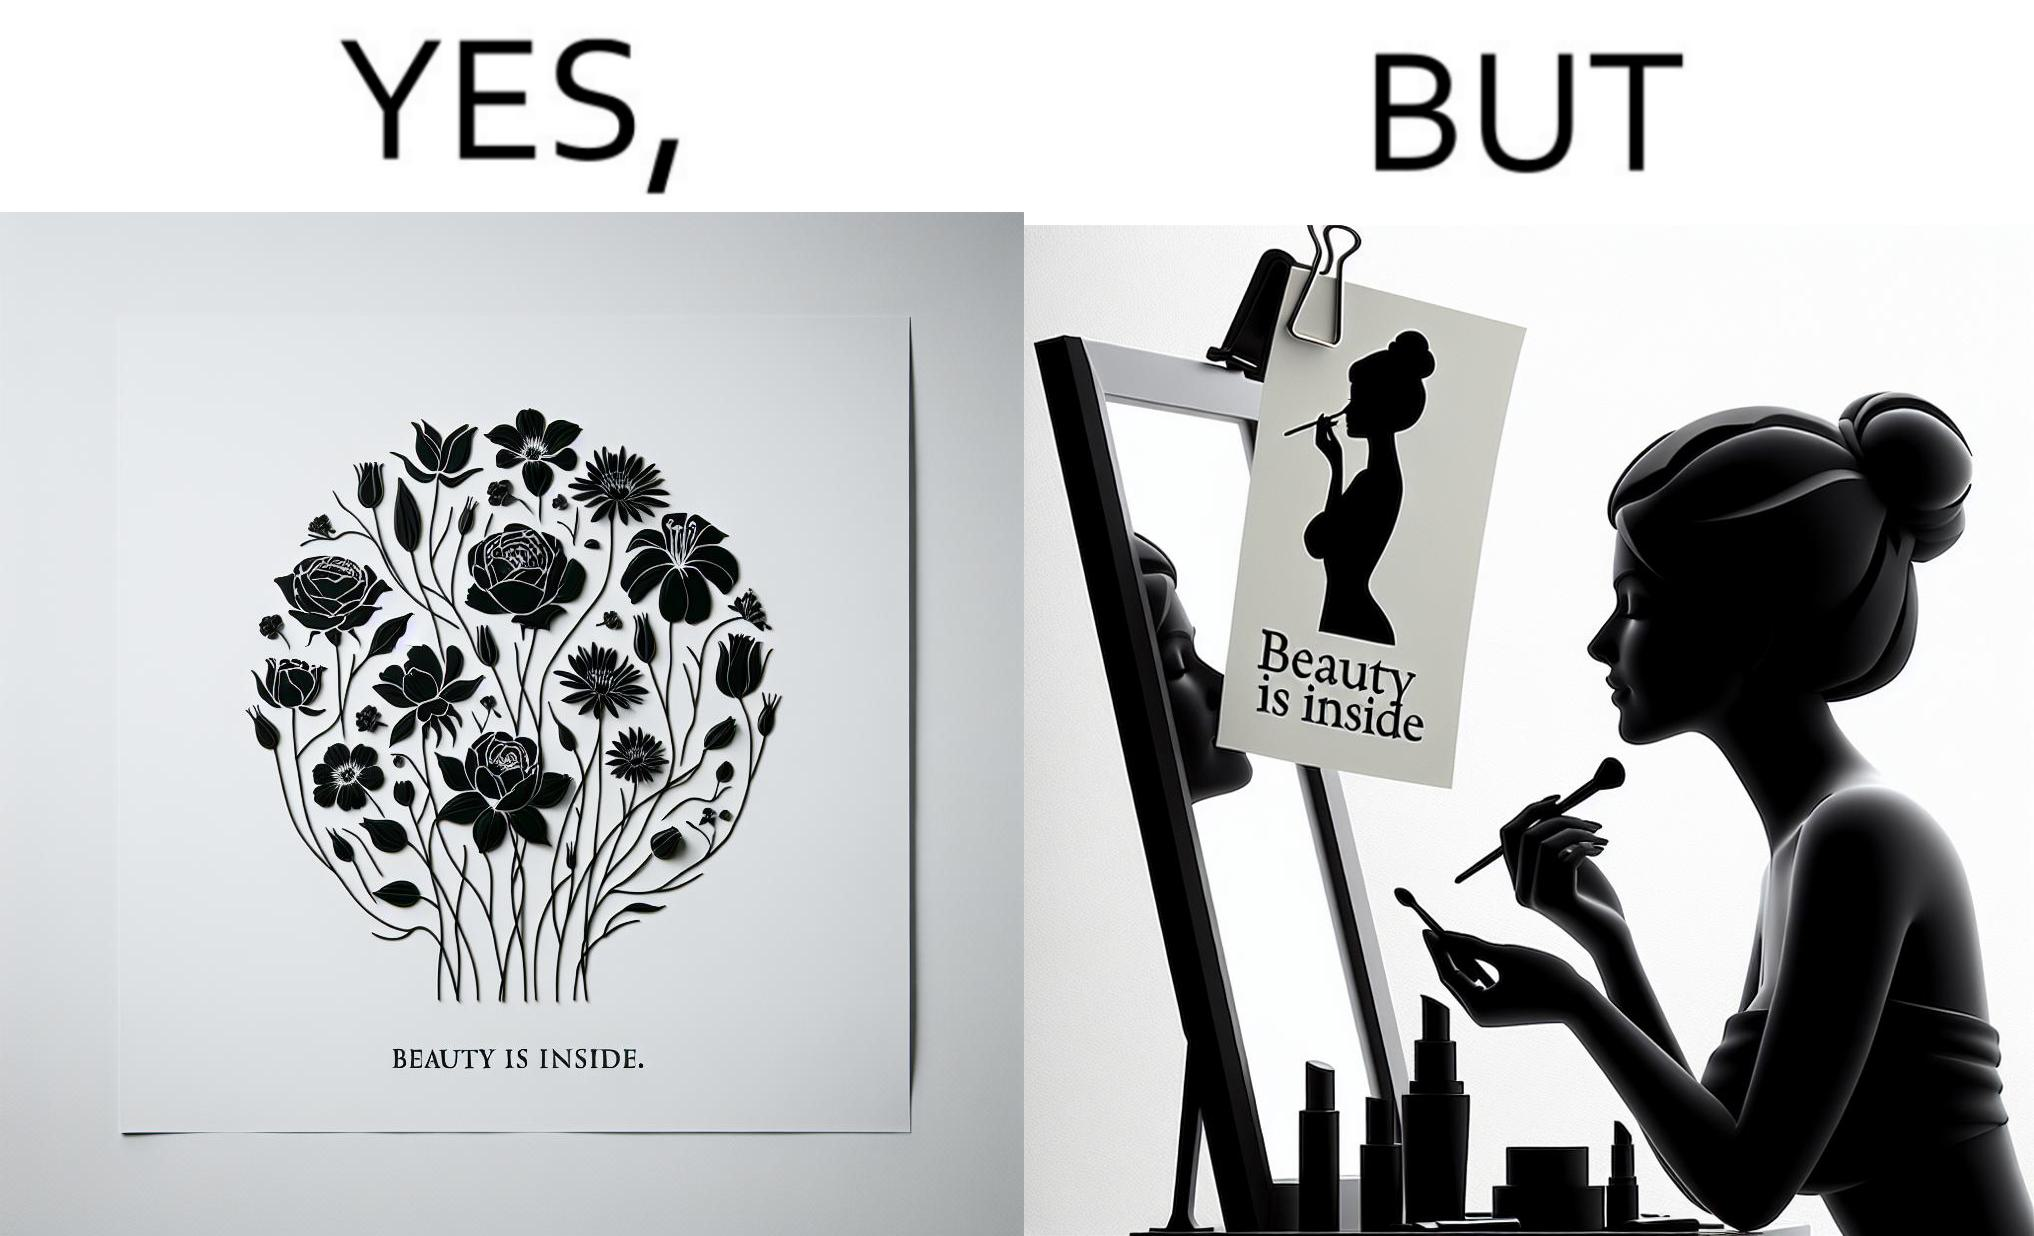What makes this image funny or satirical? The image is satirical because while the text on the paper says that beauty lies inside, the woman ignores the note and continues to apply makeup to improve her outer beauty. 